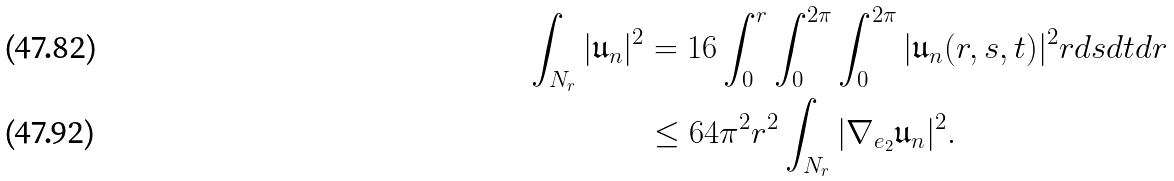<formula> <loc_0><loc_0><loc_500><loc_500>\int _ { N _ { r } } | \mathfrak { u } _ { n } | ^ { 2 } & = 1 6 \int _ { 0 } ^ { r } \int _ { 0 } ^ { 2 \pi } \int _ { 0 } ^ { 2 \pi } | \mathfrak { u } _ { n } ( r , s , t ) | ^ { 2 } r d s d t d r \\ & \leq 6 4 \pi ^ { 2 } r ^ { 2 } \int _ { N _ { r } } | \nabla _ { e _ { 2 } } \mathfrak { u } _ { n } | ^ { 2 } .</formula> 